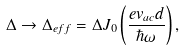<formula> <loc_0><loc_0><loc_500><loc_500>\Delta \rightarrow \Delta _ { e f f } = \Delta J _ { 0 } \left ( \frac { e v _ { a c } d } { \hbar { \omega } } \right ) ,</formula> 